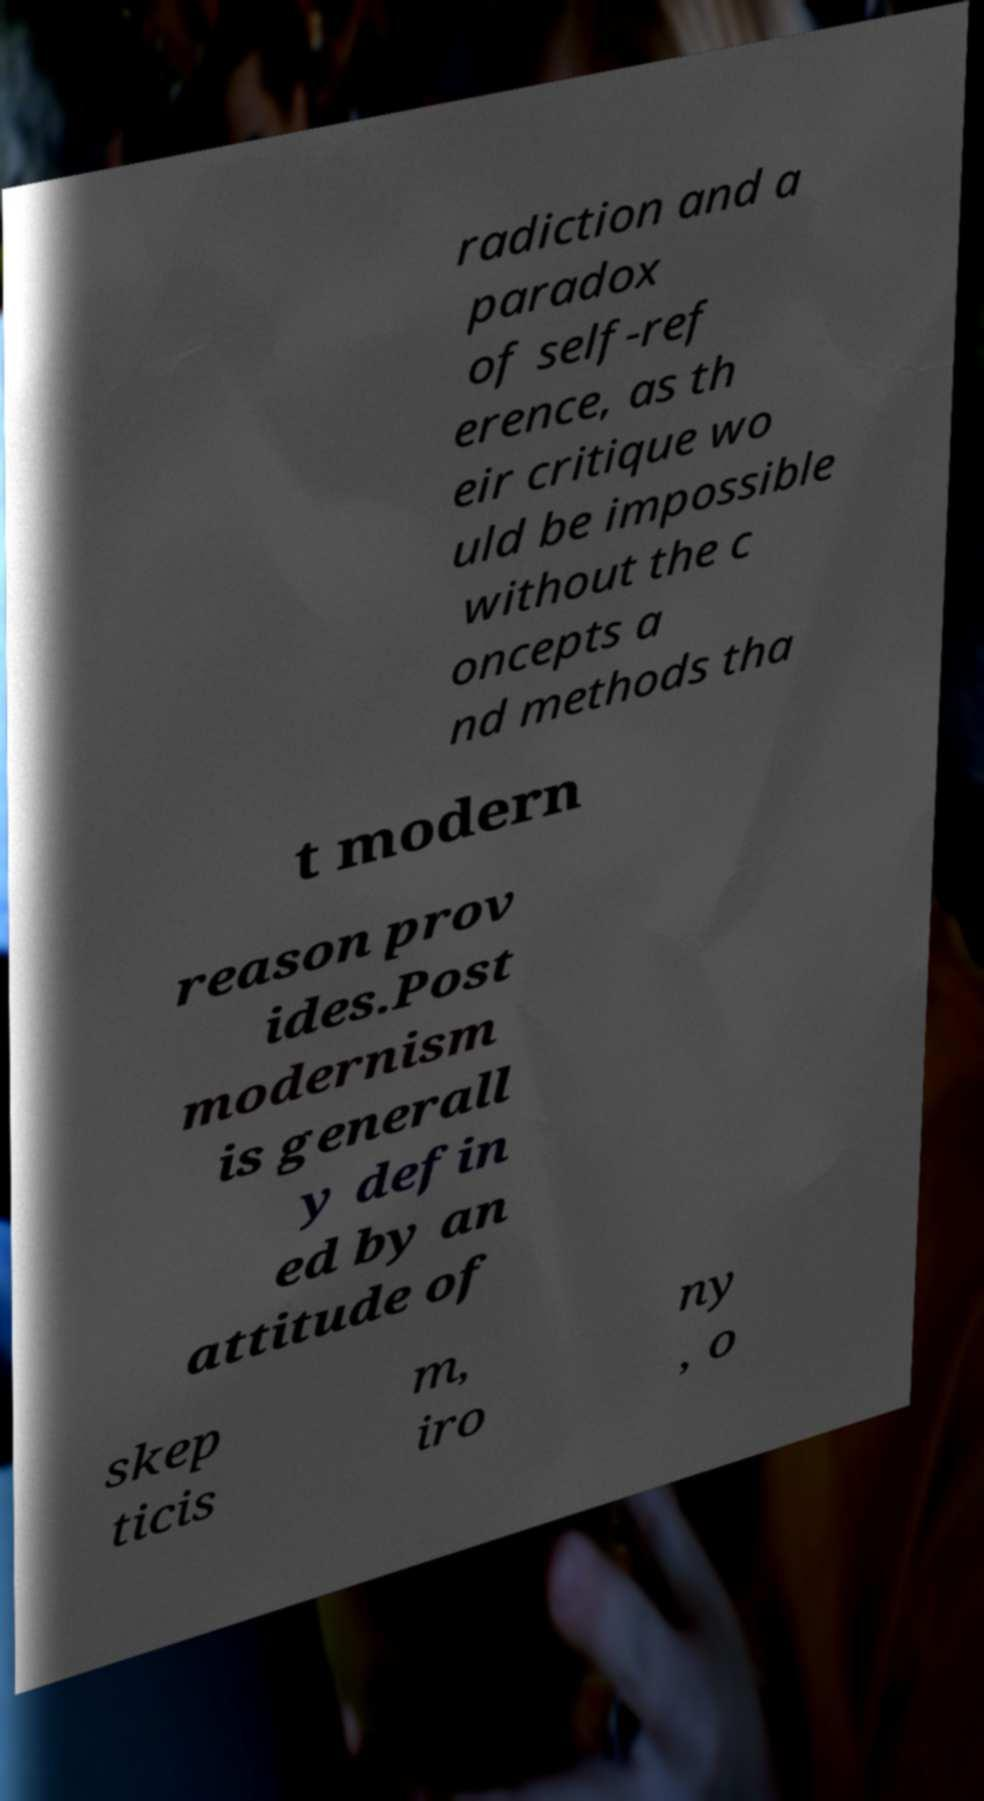Can you accurately transcribe the text from the provided image for me? radiction and a paradox of self-ref erence, as th eir critique wo uld be impossible without the c oncepts a nd methods tha t modern reason prov ides.Post modernism is generall y defin ed by an attitude of skep ticis m, iro ny , o 